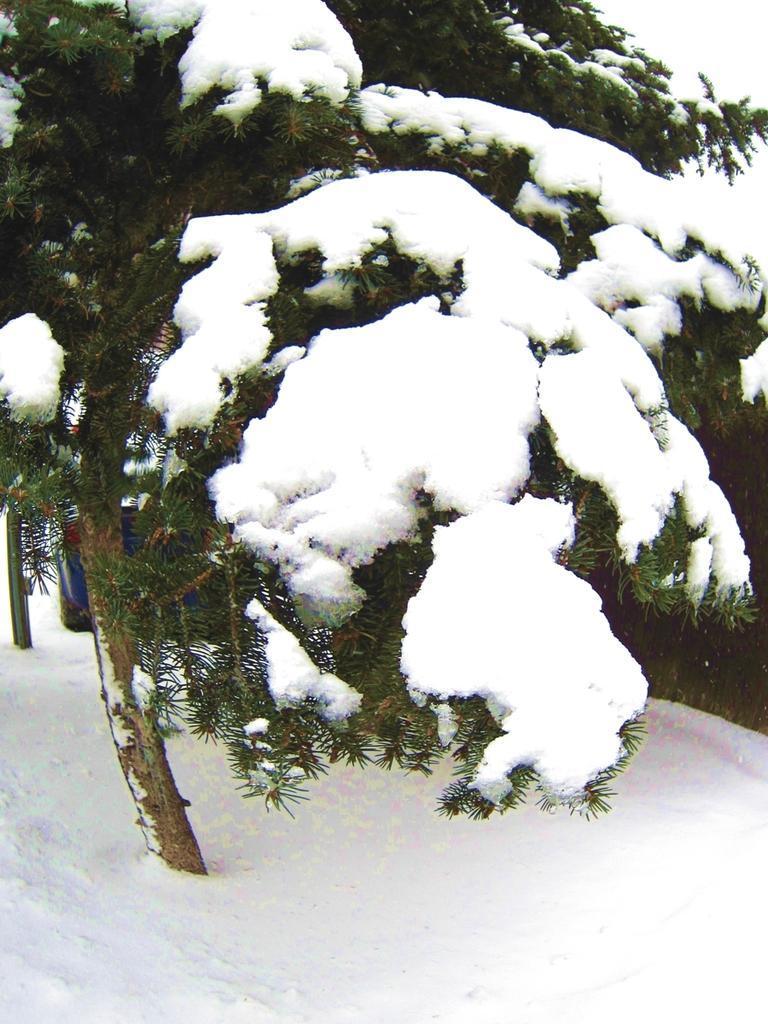Please provide a concise description of this image. In this picture we can see a tree covered with a snow. Behind this tree, we can see a vehicle in the background. 